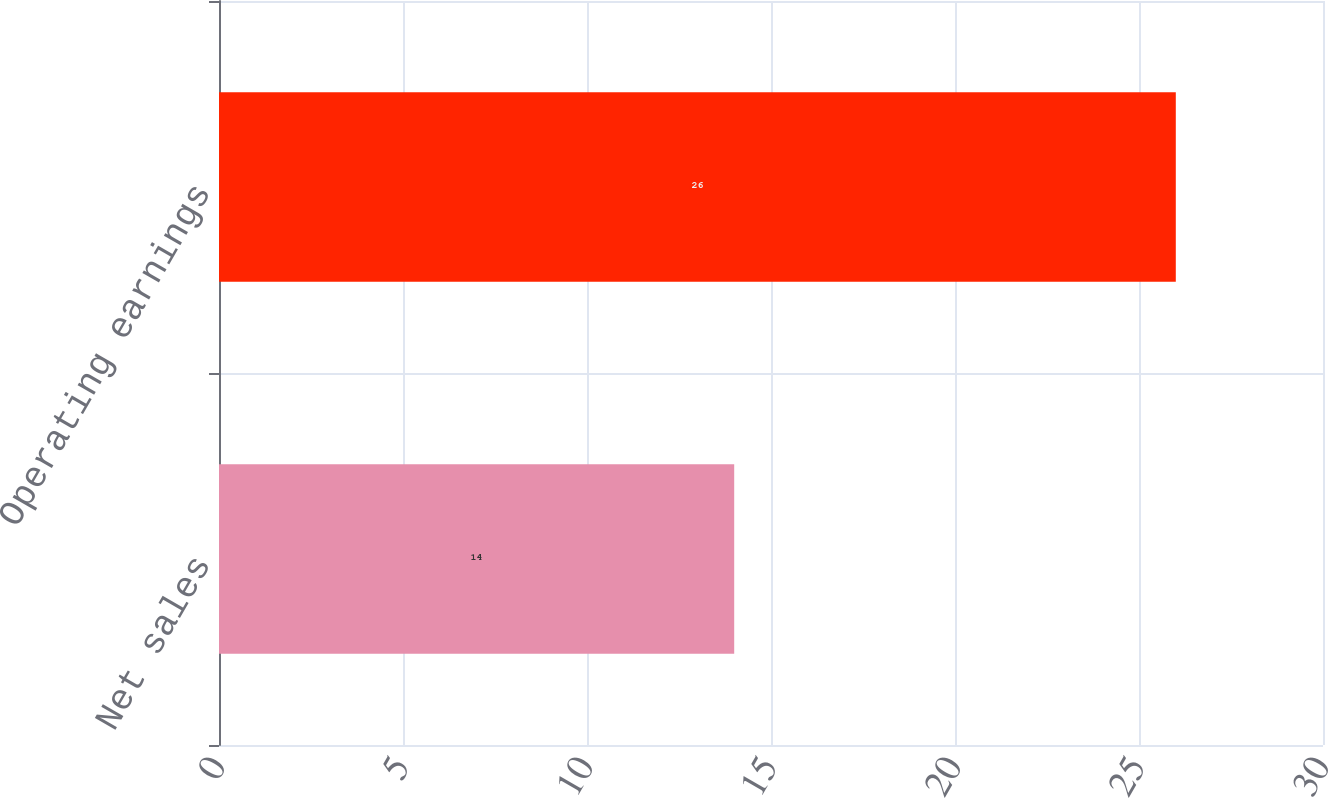<chart> <loc_0><loc_0><loc_500><loc_500><bar_chart><fcel>Net sales<fcel>Operating earnings<nl><fcel>14<fcel>26<nl></chart> 